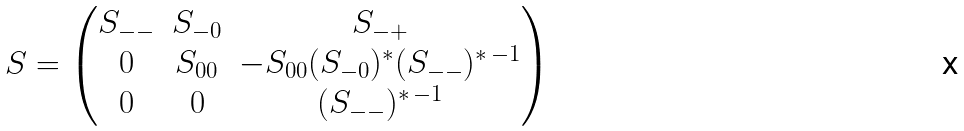Convert formula to latex. <formula><loc_0><loc_0><loc_500><loc_500>S = \begin{pmatrix} S _ { - - } & S _ { - 0 } & S _ { - + } \\ 0 & S _ { 0 0 } & - S _ { 0 0 } ( S _ { - 0 } ) ^ { \ast } ( S _ { - - } ) ^ { \ast \, - 1 } \\ 0 & 0 & ( S _ { - - } ) ^ { \ast \, - 1 } \end{pmatrix}</formula> 